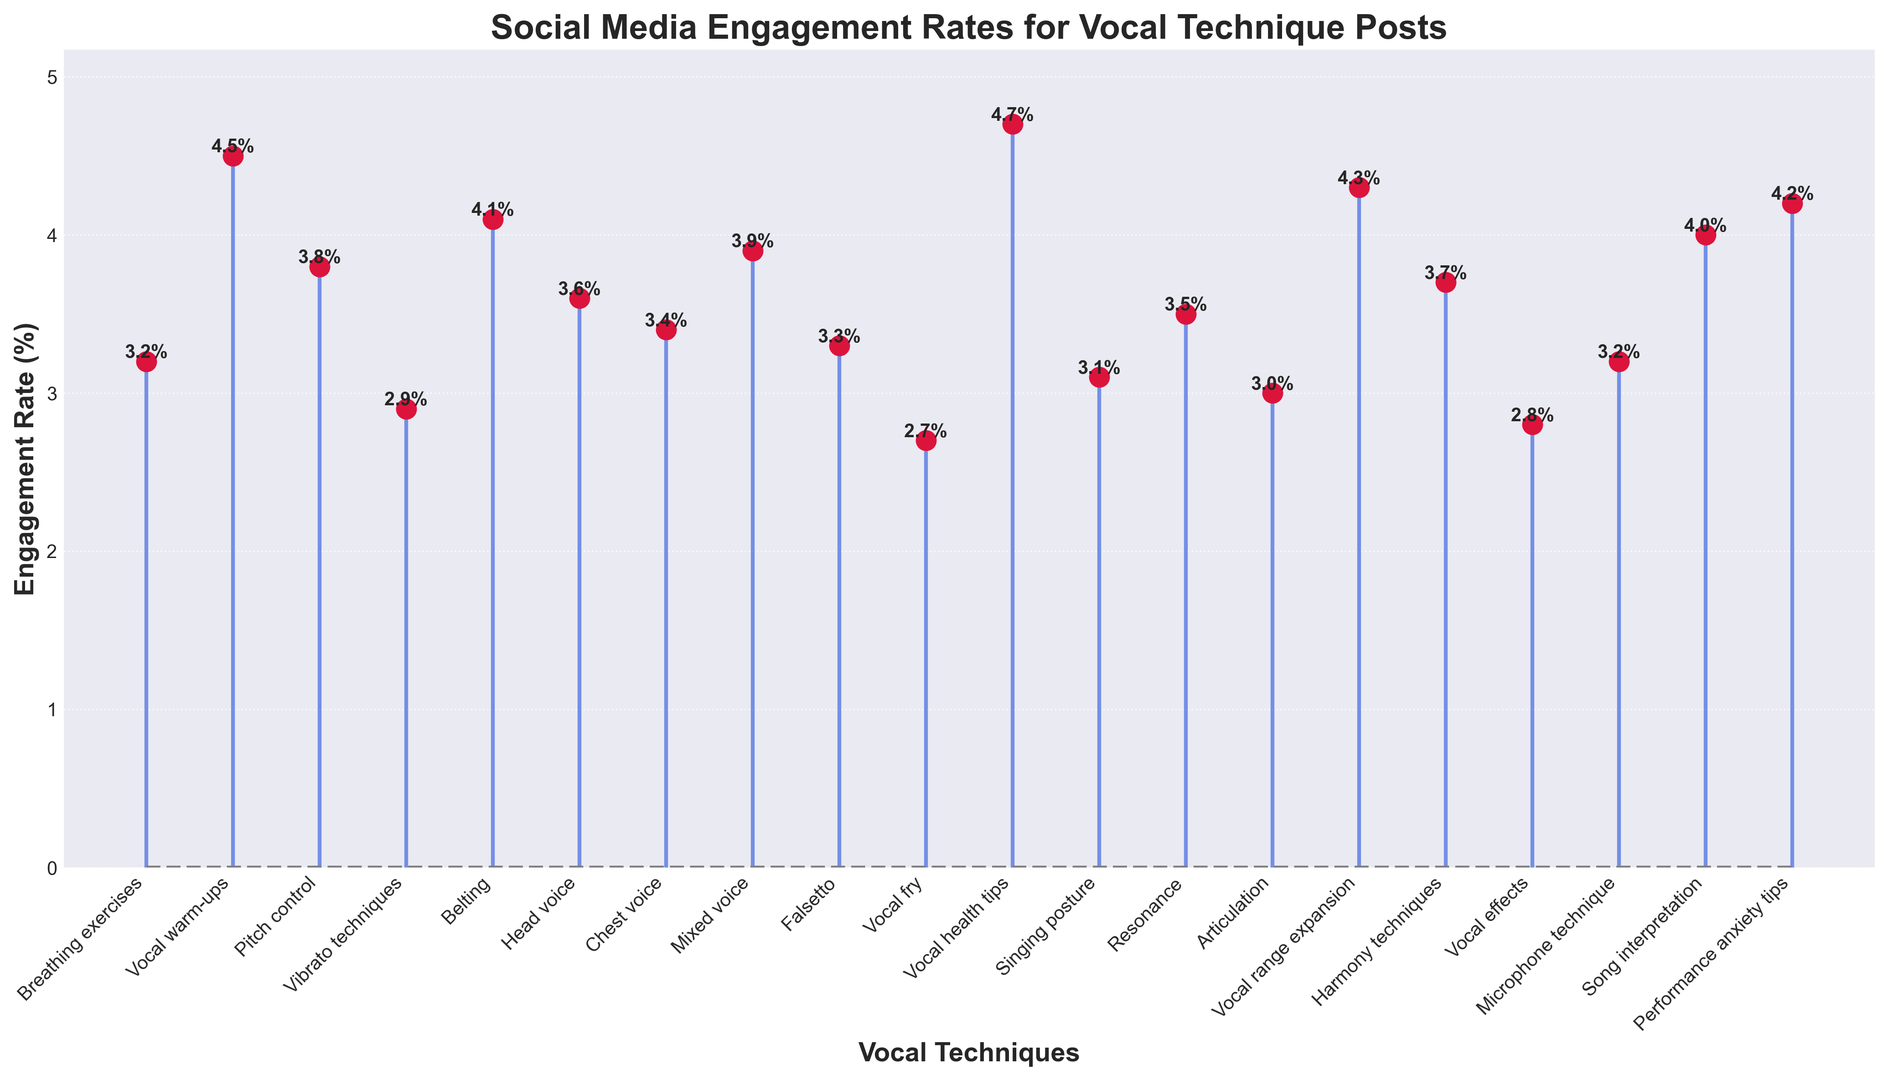What's the engagement rate for posts about vocal health tips? Locate the bar representing "Vocal health tips" and read the value on top of it, which is the highest at 4.7%
Answer: 4.7% Which topic had the lowest engagement rate? Identify the shortest stem line in the plot, which corresponds to "Vocal fry" with an engagement rate of 2.7%
Answer: Vocal fry How does the engagement rate for "Belting" compare to the rate for "Breathing exercises"? Compare the heights of the stem lines for "Belting" (4.1%) and "Breathing exercises" (3.2%). "Belting" has a higher engagement rate
Answer: Belting has a higher rate What is the average engagement rate for posts about chest voice, head voice, and mixed voice? Sum the engagement rates for the three topics (3.4 + 3.6 + 3.9) = 10.9 and then divide by 3 to find the average (10.9 / 3) = 3.63%
Answer: 3.63% What is the difference in engagement rates between the topics with the highest and lowest engagement rates? Subtract the engagement rate of the lowest topic "Vocal fry" (2.7%) from the highest "Vocal health tips" (4.7%) to get (4.7 - 2.7) = 2.0%
Answer: 2.0% Which had a higher engagement rate: "Singing posture" or "Resonance"? Compare the values for "Singing posture" (3.1%) and "Resonance" (3.5%). "Resonance" has a higher engagement rate
Answer: Resonance How do engagement rates for "Microphone technique" and "Breathing exercises" differ? "Microphone technique" has an engagement rate of 3.2% and "Breathing exercises" also at 3.2%, so they are the same.
Answer: They are the same Is "Performance anxiety tips" more engaging than "Pitch control"? By how much? Compare "Performance anxiety tips" (4.2%) with "Pitch control" (3.8%) and subtract the smaller from the larger (4.2 - 3.8) = 0.4%
Answer: Yes, by 0.4% What is the engagement rate range among the listed topics? Subtract the lowest engagement rate (2.7% for "Vocal fry") from the highest (4.7% for "Vocal health tips") to get (4.7 - 2.7) = 2.0%
Answer: 2.0% 